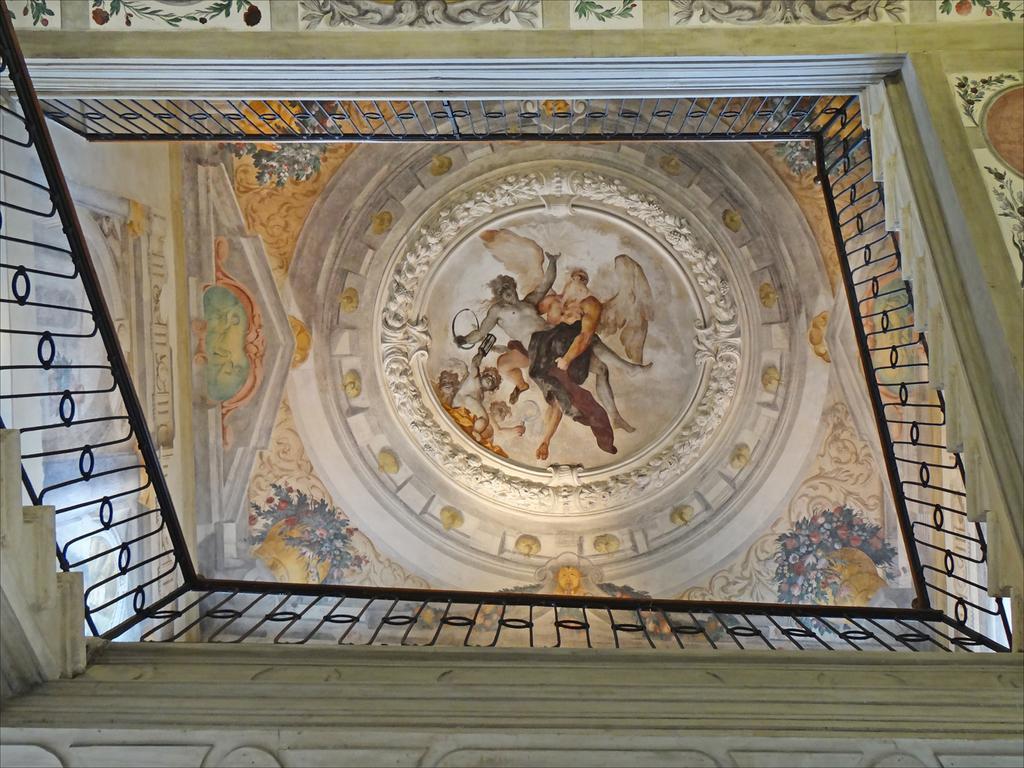Describe this image in one or two sentences. In this image , there are sculptures inside an old architect building , and there are iron grills. 